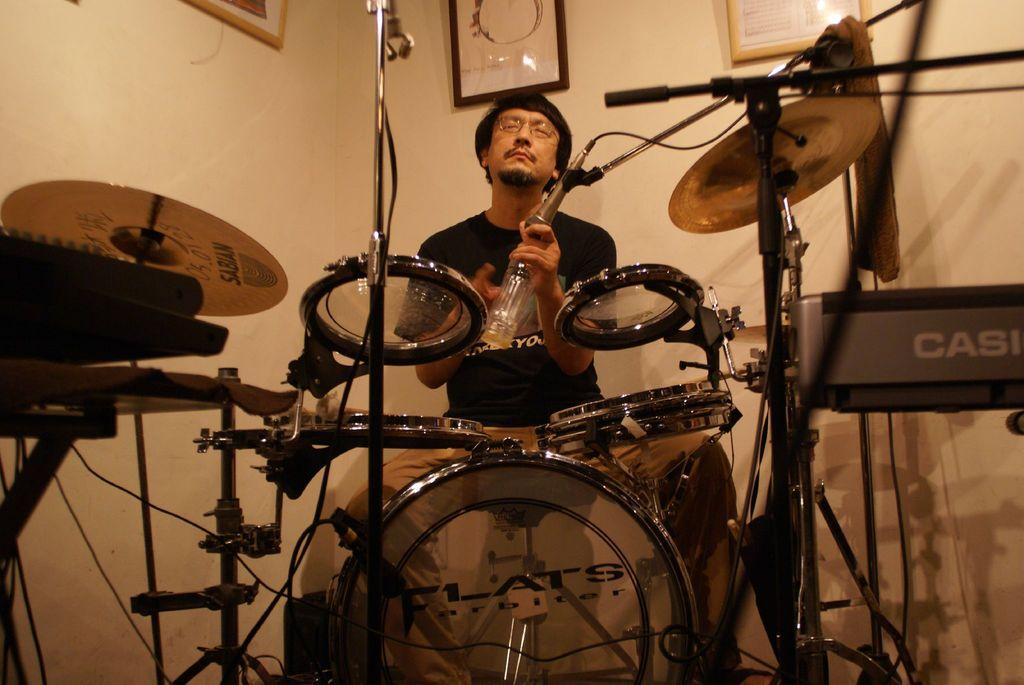What is the main subject of the image? The main subject of the image is a man. Can you describe the man's appearance? The man is wearing clothes and spectacles. What is the man doing in the image? The man is sitting. What else can be seen in the image besides the man? There are musical instruments, a cable wire, text, a wall, and frames on the wall. What type of wood is used to make the office furniture in the image? There is no office furniture present in the image, so it is not possible to determine the type of wood used. 